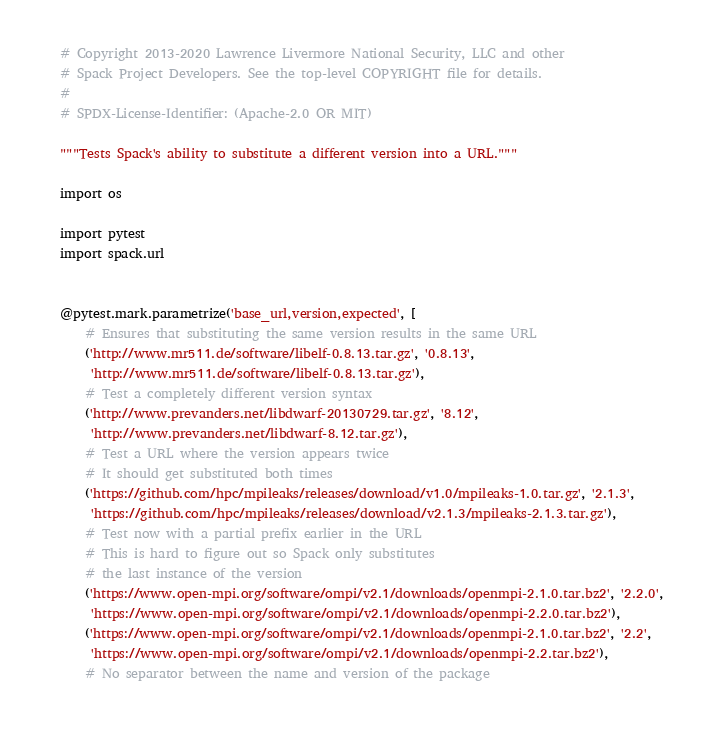<code> <loc_0><loc_0><loc_500><loc_500><_Python_># Copyright 2013-2020 Lawrence Livermore National Security, LLC and other
# Spack Project Developers. See the top-level COPYRIGHT file for details.
#
# SPDX-License-Identifier: (Apache-2.0 OR MIT)

"""Tests Spack's ability to substitute a different version into a URL."""

import os

import pytest
import spack.url


@pytest.mark.parametrize('base_url,version,expected', [
    # Ensures that substituting the same version results in the same URL
    ('http://www.mr511.de/software/libelf-0.8.13.tar.gz', '0.8.13',
     'http://www.mr511.de/software/libelf-0.8.13.tar.gz'),
    # Test a completely different version syntax
    ('http://www.prevanders.net/libdwarf-20130729.tar.gz', '8.12',
     'http://www.prevanders.net/libdwarf-8.12.tar.gz'),
    # Test a URL where the version appears twice
    # It should get substituted both times
    ('https://github.com/hpc/mpileaks/releases/download/v1.0/mpileaks-1.0.tar.gz', '2.1.3',
     'https://github.com/hpc/mpileaks/releases/download/v2.1.3/mpileaks-2.1.3.tar.gz'),
    # Test now with a partial prefix earlier in the URL
    # This is hard to figure out so Spack only substitutes
    # the last instance of the version
    ('https://www.open-mpi.org/software/ompi/v2.1/downloads/openmpi-2.1.0.tar.bz2', '2.2.0',
     'https://www.open-mpi.org/software/ompi/v2.1/downloads/openmpi-2.2.0.tar.bz2'),
    ('https://www.open-mpi.org/software/ompi/v2.1/downloads/openmpi-2.1.0.tar.bz2', '2.2',
     'https://www.open-mpi.org/software/ompi/v2.1/downloads/openmpi-2.2.tar.bz2'),
    # No separator between the name and version of the package</code> 